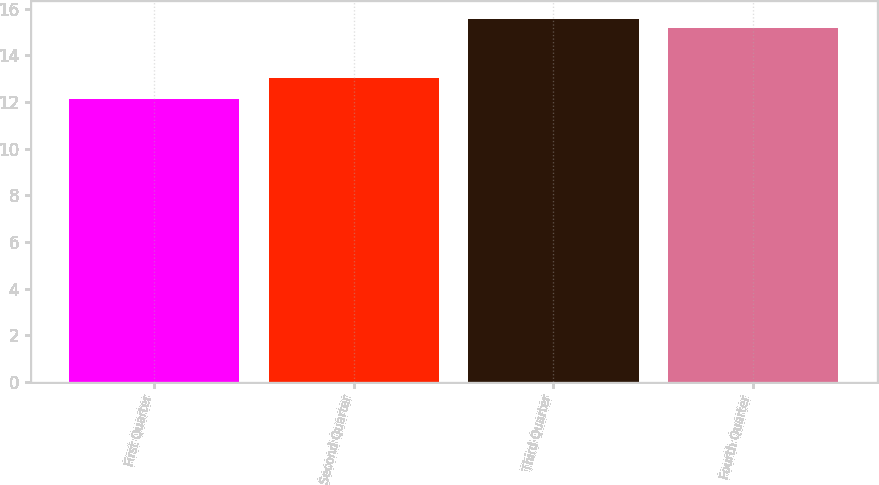Convert chart to OTSL. <chart><loc_0><loc_0><loc_500><loc_500><bar_chart><fcel>First Quarter<fcel>Second Quarter<fcel>Third Quarter<fcel>Fourth Quarter<nl><fcel>12.13<fcel>13.05<fcel>15.56<fcel>15.18<nl></chart> 